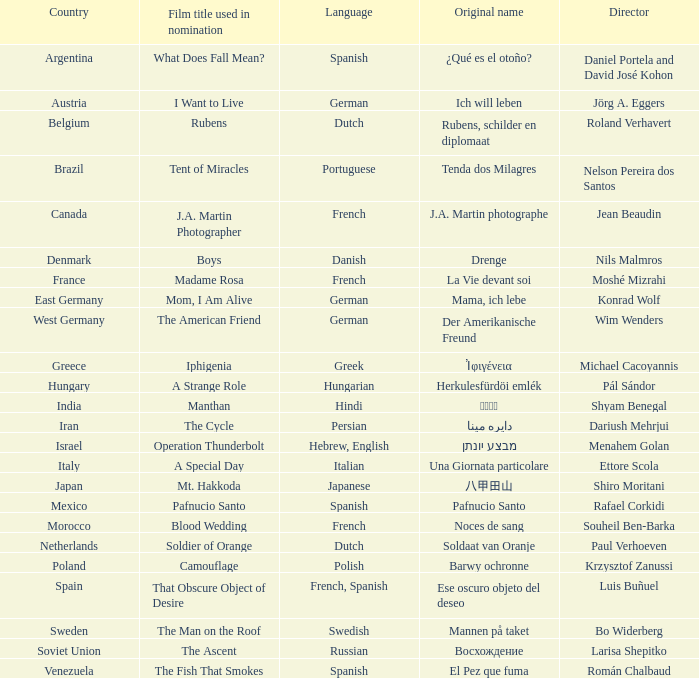What country does the cinema tent of miracles originate from? Brazil. 